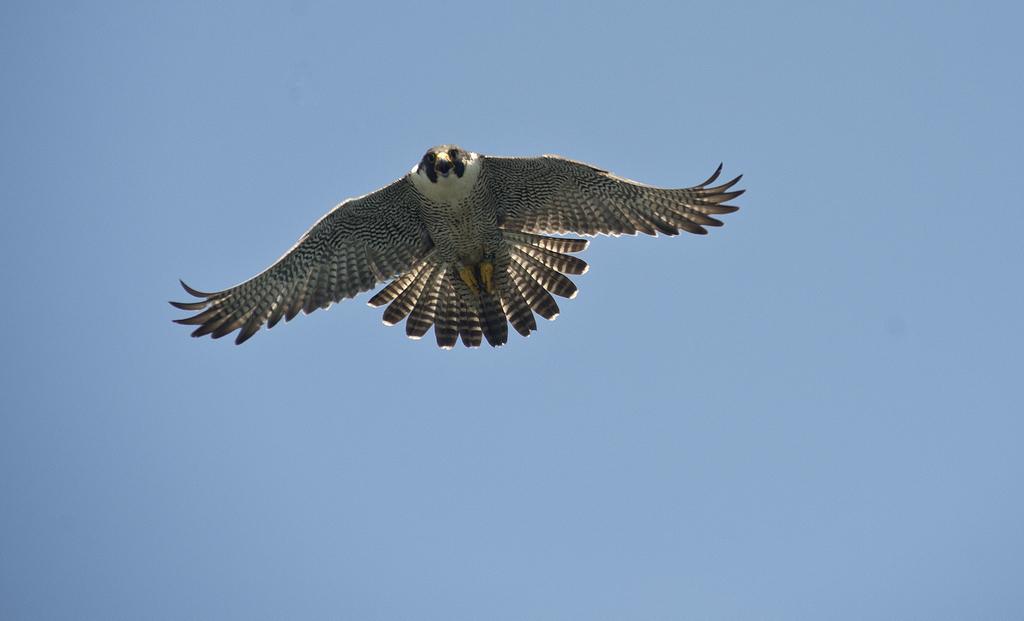Describe this image in one or two sentences. In this image, we can see a bird flying in the air, we can see the blue sky. 